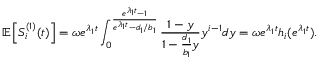Convert formula to latex. <formula><loc_0><loc_0><loc_500><loc_500>\mathbb { E } \left [ S _ { i } ^ { ( 1 ) } ( t ) \right ] = \omega e ^ { \lambda _ { 1 } t } \int _ { 0 } ^ { \frac { e ^ { \lambda _ { 1 } t } - 1 } { e ^ { \lambda _ { 1 } t } - d _ { 1 } / b _ { 1 } } } \frac { 1 - y } { 1 - \frac { d _ { 1 } } { b _ { 1 } } y } y ^ { i - 1 } d y = \omega e ^ { \lambda _ { 1 } t } h _ { i } ( e ^ { \lambda _ { 1 } t } ) .</formula> 